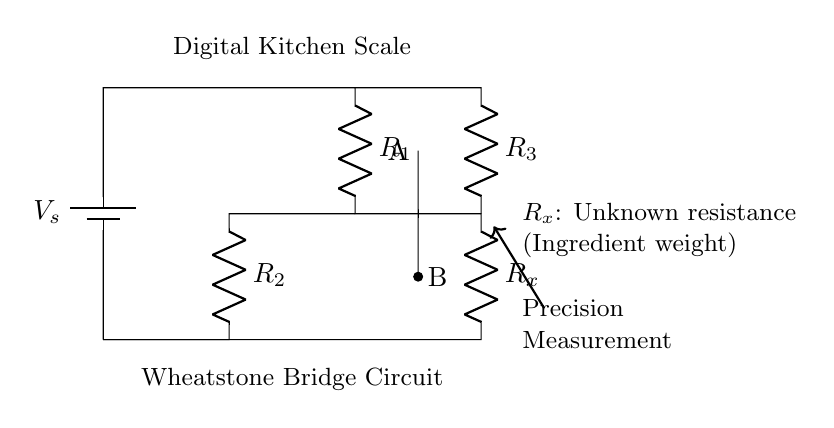What does 'R_x' represent in the circuit? 'R_x' represents the unknown resistance, which correlates to the weight of the ingredient being measured. It is an essential part of the Wheatstone bridge.
Answer: unknown resistance How many resistors are present in this circuit? The circuit shows a total of four resistors: R_1, R_2, R_3, and R_x. Each plays a role in balancing the bridge.
Answer: four What is the purpose of the Wheatstone bridge in this setup? The purpose of the Wheatstone bridge is to measure the precise resistance value (and hence the weight) of the ingredient accurately. The bridge can indicate when it's balanced, which corresponds to a specific weight.
Answer: precise measurement What is the role of the battery in the Wheatstone bridge? The battery supplies the necessary voltage (V_s) to the circuit so that the current can flow through the resistors, enabling the measurement of resistance based on current variations.
Answer: supplies voltage Which resistors are in parallel in this circuit? Resistors R_2 and R_3 are configured in a way where they connect to the same two nodes, thus they are in parallel. This structure allows for a shared voltage across them while the current splits.
Answer: R_2 and R_3 If R_1 equals R_2, what can be said about R_x and R_3? If R_1 equals R_2 in a balanced Wheatstone bridge, then R_x must equal R_3 for the bridge to be balanced, indicating that the ingredient's resistance corresponds directly to the set resistance.
Answer: R_x equals R_3 